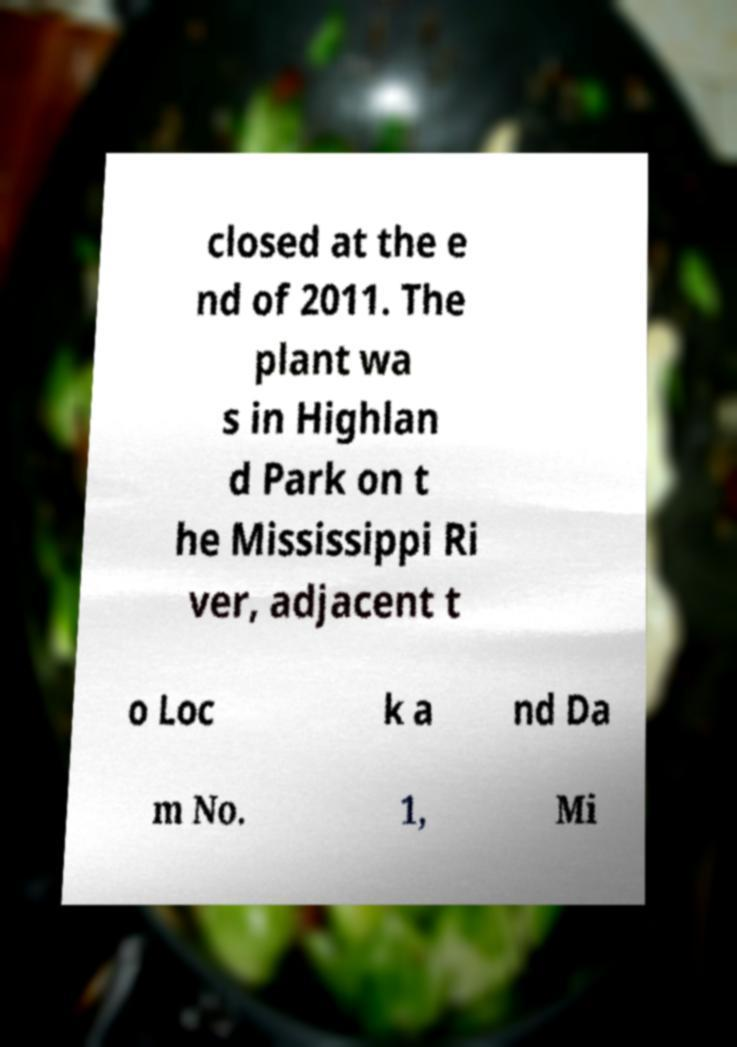There's text embedded in this image that I need extracted. Can you transcribe it verbatim? closed at the e nd of 2011. The plant wa s in Highlan d Park on t he Mississippi Ri ver, adjacent t o Loc k a nd Da m No. 1, Mi 